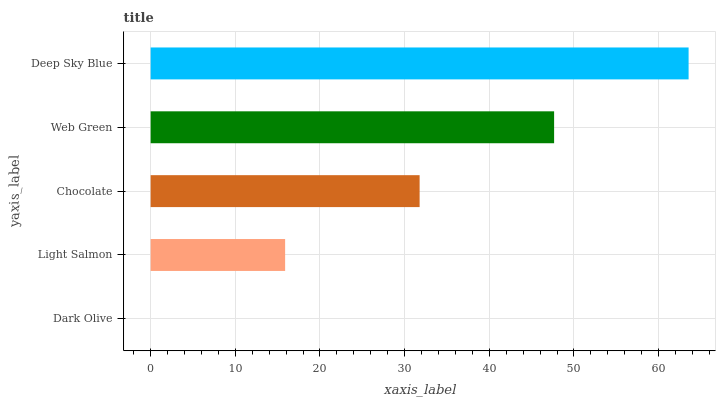Is Dark Olive the minimum?
Answer yes or no. Yes. Is Deep Sky Blue the maximum?
Answer yes or no. Yes. Is Light Salmon the minimum?
Answer yes or no. No. Is Light Salmon the maximum?
Answer yes or no. No. Is Light Salmon greater than Dark Olive?
Answer yes or no. Yes. Is Dark Olive less than Light Salmon?
Answer yes or no. Yes. Is Dark Olive greater than Light Salmon?
Answer yes or no. No. Is Light Salmon less than Dark Olive?
Answer yes or no. No. Is Chocolate the high median?
Answer yes or no. Yes. Is Chocolate the low median?
Answer yes or no. Yes. Is Web Green the high median?
Answer yes or no. No. Is Light Salmon the low median?
Answer yes or no. No. 